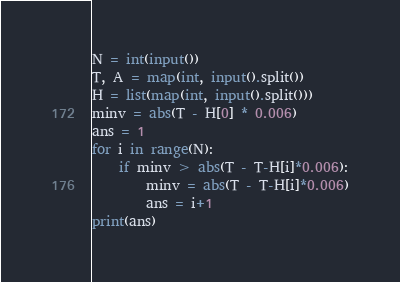Convert code to text. <code><loc_0><loc_0><loc_500><loc_500><_Python_>N = int(input())
T, A = map(int, input().split())
H = list(map(int, input().split()))
minv = abs(T - H[0] * 0.006)
ans = 1
for i in range(N):
    if minv > abs(T - T-H[i]*0.006):
        minv = abs(T - T-H[i]*0.006)
        ans = i+1
print(ans)</code> 